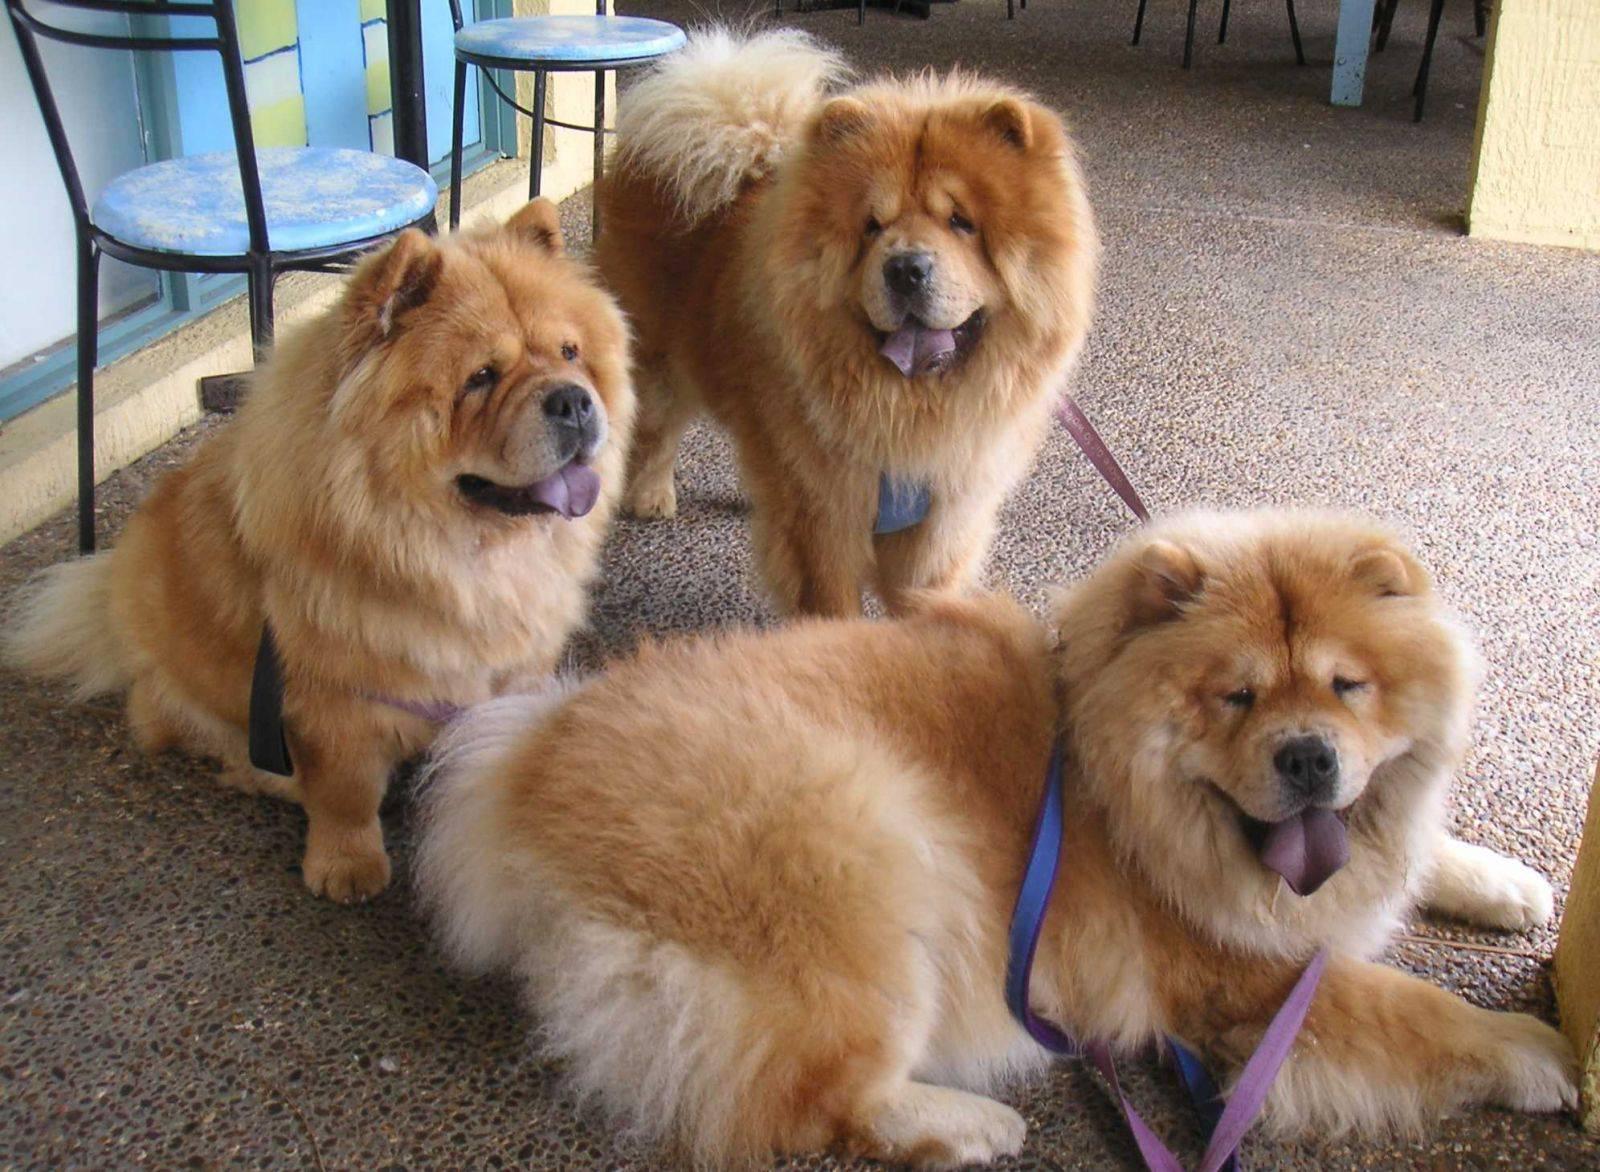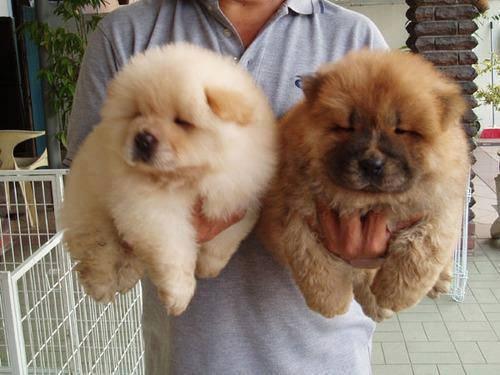The first image is the image on the left, the second image is the image on the right. Examine the images to the left and right. Is the description "A man in a light blue shirt is holding two puppies." accurate? Answer yes or no. Yes. The first image is the image on the left, the second image is the image on the right. Assess this claim about the two images: "There is a human in the image on the right.". Correct or not? Answer yes or no. Yes. 